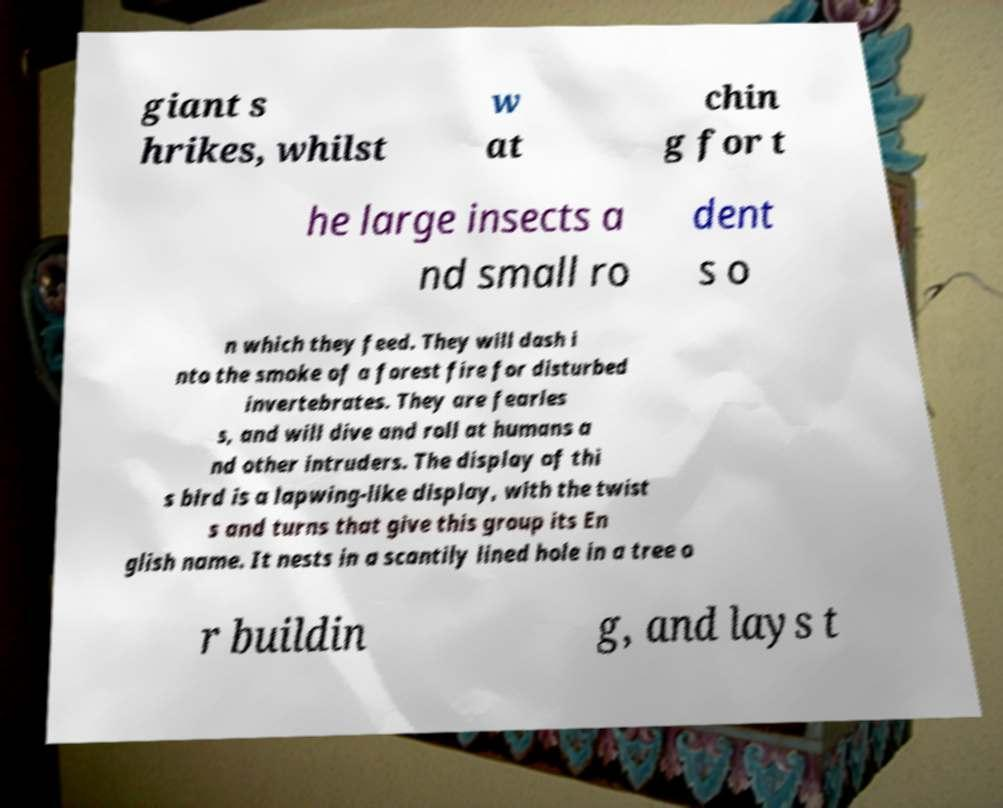Please identify and transcribe the text found in this image. giant s hrikes, whilst w at chin g for t he large insects a nd small ro dent s o n which they feed. They will dash i nto the smoke of a forest fire for disturbed invertebrates. They are fearles s, and will dive and roll at humans a nd other intruders. The display of thi s bird is a lapwing-like display, with the twist s and turns that give this group its En glish name. It nests in a scantily lined hole in a tree o r buildin g, and lays t 